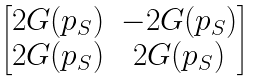<formula> <loc_0><loc_0><loc_500><loc_500>\begin{bmatrix} 2 G ( p _ { S } ) & - 2 G ( p _ { S } ) \\ 2 G ( p _ { S } ) & 2 G ( p _ { S } ) \end{bmatrix}</formula> 